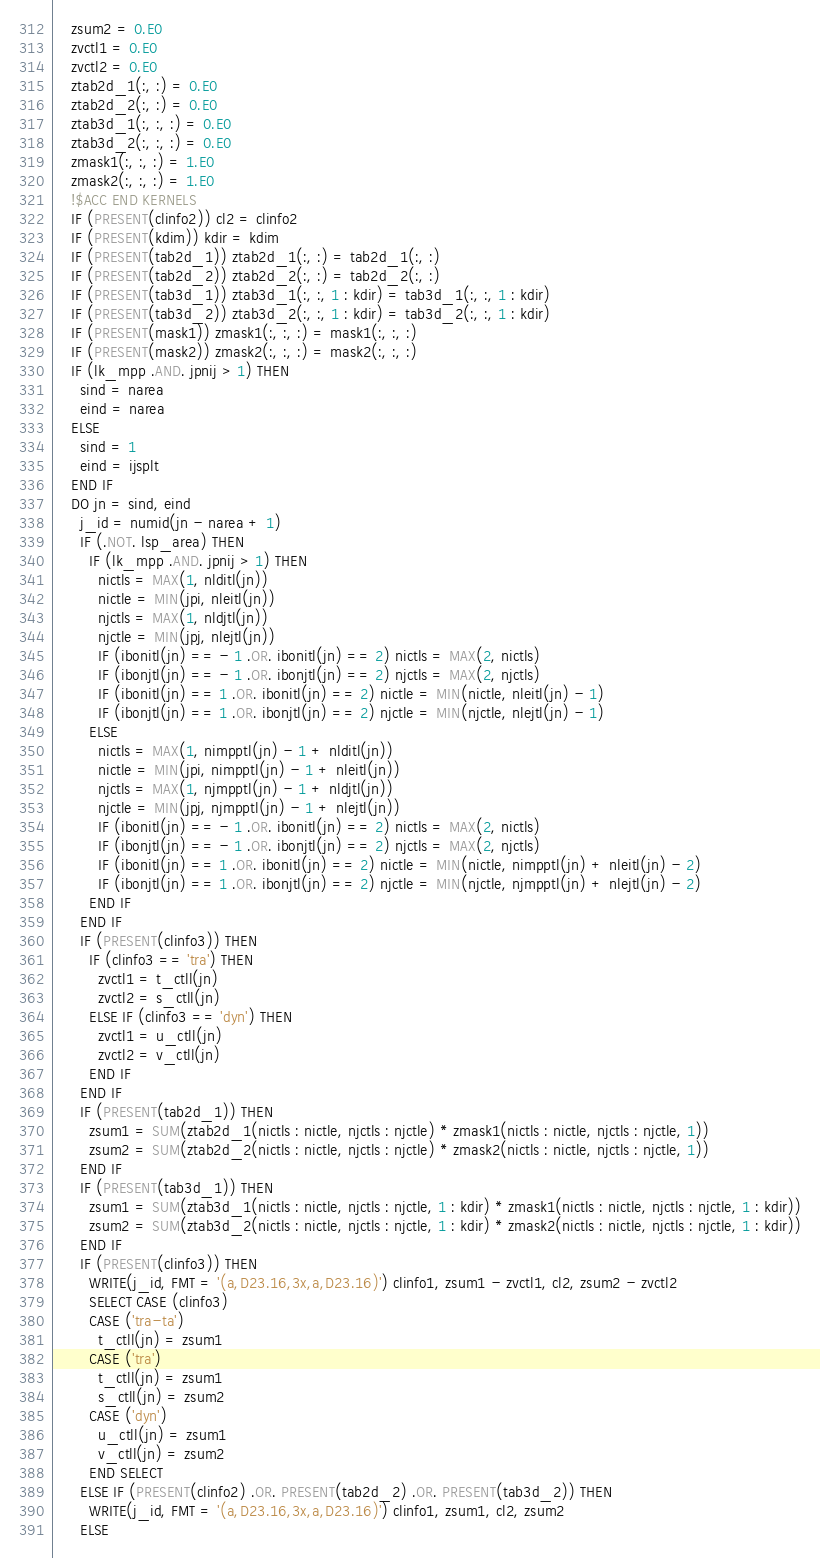Convert code to text. <code><loc_0><loc_0><loc_500><loc_500><_FORTRAN_>    zsum2 = 0.E0
    zvctl1 = 0.E0
    zvctl2 = 0.E0
    ztab2d_1(:, :) = 0.E0
    ztab2d_2(:, :) = 0.E0
    ztab3d_1(:, :, :) = 0.E0
    ztab3d_2(:, :, :) = 0.E0
    zmask1(:, :, :) = 1.E0
    zmask2(:, :, :) = 1.E0
    !$ACC END KERNELS
    IF (PRESENT(clinfo2)) cl2 = clinfo2
    IF (PRESENT(kdim)) kdir = kdim
    IF (PRESENT(tab2d_1)) ztab2d_1(:, :) = tab2d_1(:, :)
    IF (PRESENT(tab2d_2)) ztab2d_2(:, :) = tab2d_2(:, :)
    IF (PRESENT(tab3d_1)) ztab3d_1(:, :, 1 : kdir) = tab3d_1(:, :, 1 : kdir)
    IF (PRESENT(tab3d_2)) ztab3d_2(:, :, 1 : kdir) = tab3d_2(:, :, 1 : kdir)
    IF (PRESENT(mask1)) zmask1(:, :, :) = mask1(:, :, :)
    IF (PRESENT(mask2)) zmask2(:, :, :) = mask2(:, :, :)
    IF (lk_mpp .AND. jpnij > 1) THEN
      sind = narea
      eind = narea
    ELSE
      sind = 1
      eind = ijsplt
    END IF
    DO jn = sind, eind
      j_id = numid(jn - narea + 1)
      IF (.NOT. lsp_area) THEN
        IF (lk_mpp .AND. jpnij > 1) THEN
          nictls = MAX(1, nlditl(jn))
          nictle = MIN(jpi, nleitl(jn))
          njctls = MAX(1, nldjtl(jn))
          njctle = MIN(jpj, nlejtl(jn))
          IF (ibonitl(jn) == - 1 .OR. ibonitl(jn) == 2) nictls = MAX(2, nictls)
          IF (ibonjtl(jn) == - 1 .OR. ibonjtl(jn) == 2) njctls = MAX(2, njctls)
          IF (ibonitl(jn) == 1 .OR. ibonitl(jn) == 2) nictle = MIN(nictle, nleitl(jn) - 1)
          IF (ibonjtl(jn) == 1 .OR. ibonjtl(jn) == 2) njctle = MIN(njctle, nlejtl(jn) - 1)
        ELSE
          nictls = MAX(1, nimpptl(jn) - 1 + nlditl(jn))
          nictle = MIN(jpi, nimpptl(jn) - 1 + nleitl(jn))
          njctls = MAX(1, njmpptl(jn) - 1 + nldjtl(jn))
          njctle = MIN(jpj, njmpptl(jn) - 1 + nlejtl(jn))
          IF (ibonitl(jn) == - 1 .OR. ibonitl(jn) == 2) nictls = MAX(2, nictls)
          IF (ibonjtl(jn) == - 1 .OR. ibonjtl(jn) == 2) njctls = MAX(2, njctls)
          IF (ibonitl(jn) == 1 .OR. ibonitl(jn) == 2) nictle = MIN(nictle, nimpptl(jn) + nleitl(jn) - 2)
          IF (ibonjtl(jn) == 1 .OR. ibonjtl(jn) == 2) njctle = MIN(njctle, njmpptl(jn) + nlejtl(jn) - 2)
        END IF
      END IF
      IF (PRESENT(clinfo3)) THEN
        IF (clinfo3 == 'tra') THEN
          zvctl1 = t_ctll(jn)
          zvctl2 = s_ctll(jn)
        ELSE IF (clinfo3 == 'dyn') THEN
          zvctl1 = u_ctll(jn)
          zvctl2 = v_ctll(jn)
        END IF
      END IF
      IF (PRESENT(tab2d_1)) THEN
        zsum1 = SUM(ztab2d_1(nictls : nictle, njctls : njctle) * zmask1(nictls : nictle, njctls : njctle, 1))
        zsum2 = SUM(ztab2d_2(nictls : nictle, njctls : njctle) * zmask2(nictls : nictle, njctls : njctle, 1))
      END IF
      IF (PRESENT(tab3d_1)) THEN
        zsum1 = SUM(ztab3d_1(nictls : nictle, njctls : njctle, 1 : kdir) * zmask1(nictls : nictle, njctls : njctle, 1 : kdir))
        zsum2 = SUM(ztab3d_2(nictls : nictle, njctls : njctle, 1 : kdir) * zmask2(nictls : nictle, njctls : njctle, 1 : kdir))
      END IF
      IF (PRESENT(clinfo3)) THEN
        WRITE(j_id, FMT = '(a,D23.16,3x,a,D23.16)') clinfo1, zsum1 - zvctl1, cl2, zsum2 - zvctl2
        SELECT CASE (clinfo3)
        CASE ('tra-ta')
          t_ctll(jn) = zsum1
        CASE ('tra')
          t_ctll(jn) = zsum1
          s_ctll(jn) = zsum2
        CASE ('dyn')
          u_ctll(jn) = zsum1
          v_ctll(jn) = zsum2
        END SELECT
      ELSE IF (PRESENT(clinfo2) .OR. PRESENT(tab2d_2) .OR. PRESENT(tab3d_2)) THEN
        WRITE(j_id, FMT = '(a,D23.16,3x,a,D23.16)') clinfo1, zsum1, cl2, zsum2
      ELSE</code> 